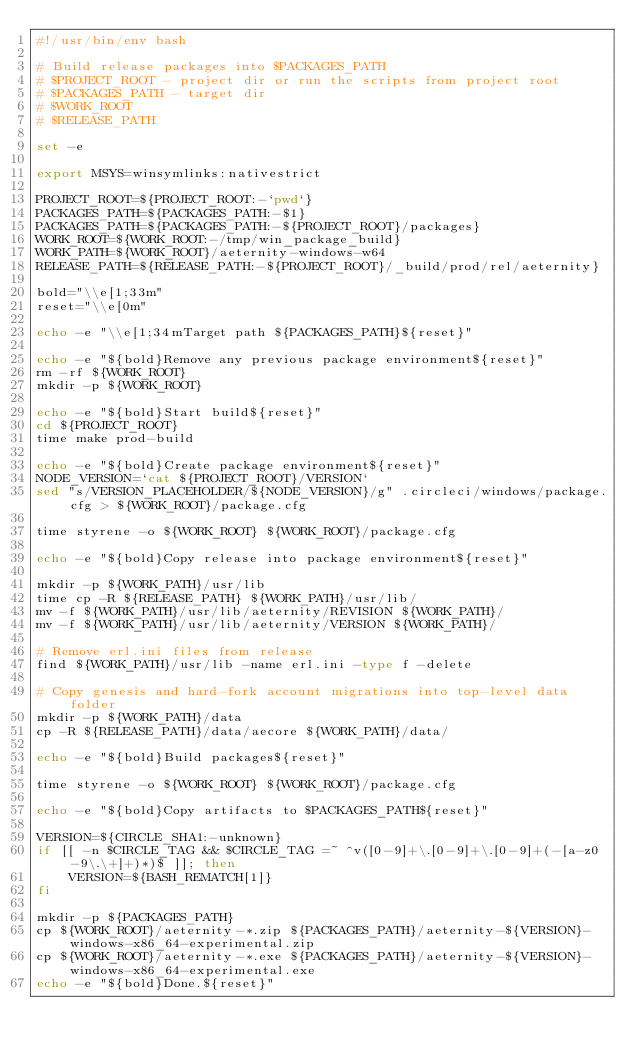<code> <loc_0><loc_0><loc_500><loc_500><_Bash_>#!/usr/bin/env bash

# Build release packages into $PACKAGES_PATH
# $PROJECT_ROOT - project dir or run the scripts from project root
# $PACKAGES_PATH - target dir
# $WORK_ROOT
# $RELEASE_PATH

set -e

export MSYS=winsymlinks:nativestrict

PROJECT_ROOT=${PROJECT_ROOT:-`pwd`}
PACKAGES_PATH=${PACKAGES_PATH:-$1}
PACKAGES_PATH=${PACKAGES_PATH:-${PROJECT_ROOT}/packages}
WORK_ROOT=${WORK_ROOT:-/tmp/win_package_build}
WORK_PATH=${WORK_ROOT}/aeternity-windows-w64
RELEASE_PATH=${RELEASE_PATH:-${PROJECT_ROOT}/_build/prod/rel/aeternity}

bold="\\e[1;33m"
reset="\\e[0m"

echo -e "\\e[1;34mTarget path ${PACKAGES_PATH}${reset}"

echo -e "${bold}Remove any previous package environment${reset}"
rm -rf ${WORK_ROOT}
mkdir -p ${WORK_ROOT}

echo -e "${bold}Start build${reset}"
cd ${PROJECT_ROOT}
time make prod-build

echo -e "${bold}Create package environment${reset}"
NODE_VERSION=`cat ${PROJECT_ROOT}/VERSION`
sed "s/VERSION_PLACEHOLDER/${NODE_VERSION}/g" .circleci/windows/package.cfg > ${WORK_ROOT}/package.cfg

time styrene -o ${WORK_ROOT} ${WORK_ROOT}/package.cfg

echo -e "${bold}Copy release into package environment${reset}"

mkdir -p ${WORK_PATH}/usr/lib
time cp -R ${RELEASE_PATH} ${WORK_PATH}/usr/lib/
mv -f ${WORK_PATH}/usr/lib/aeternity/REVISION ${WORK_PATH}/
mv -f ${WORK_PATH}/usr/lib/aeternity/VERSION ${WORK_PATH}/

# Remove erl.ini files from release
find ${WORK_PATH}/usr/lib -name erl.ini -type f -delete

# Copy genesis and hard-fork account migrations into top-level data folder
mkdir -p ${WORK_PATH}/data
cp -R ${RELEASE_PATH}/data/aecore ${WORK_PATH}/data/

echo -e "${bold}Build packages${reset}"

time styrene -o ${WORK_ROOT} ${WORK_ROOT}/package.cfg

echo -e "${bold}Copy artifacts to $PACKAGES_PATH${reset}"

VERSION=${CIRCLE_SHA1:-unknown}
if [[ -n $CIRCLE_TAG && $CIRCLE_TAG =~ ^v([0-9]+\.[0-9]+\.[0-9]+(-[a-z0-9\.\+]+)*)$ ]]; then
    VERSION=${BASH_REMATCH[1]}
fi

mkdir -p ${PACKAGES_PATH}
cp ${WORK_ROOT}/aeternity-*.zip ${PACKAGES_PATH}/aeternity-${VERSION}-windows-x86_64-experimental.zip
cp ${WORK_ROOT}/aeternity-*.exe ${PACKAGES_PATH}/aeternity-${VERSION}-windows-x86_64-experimental.exe
echo -e "${bold}Done.${reset}"
</code> 